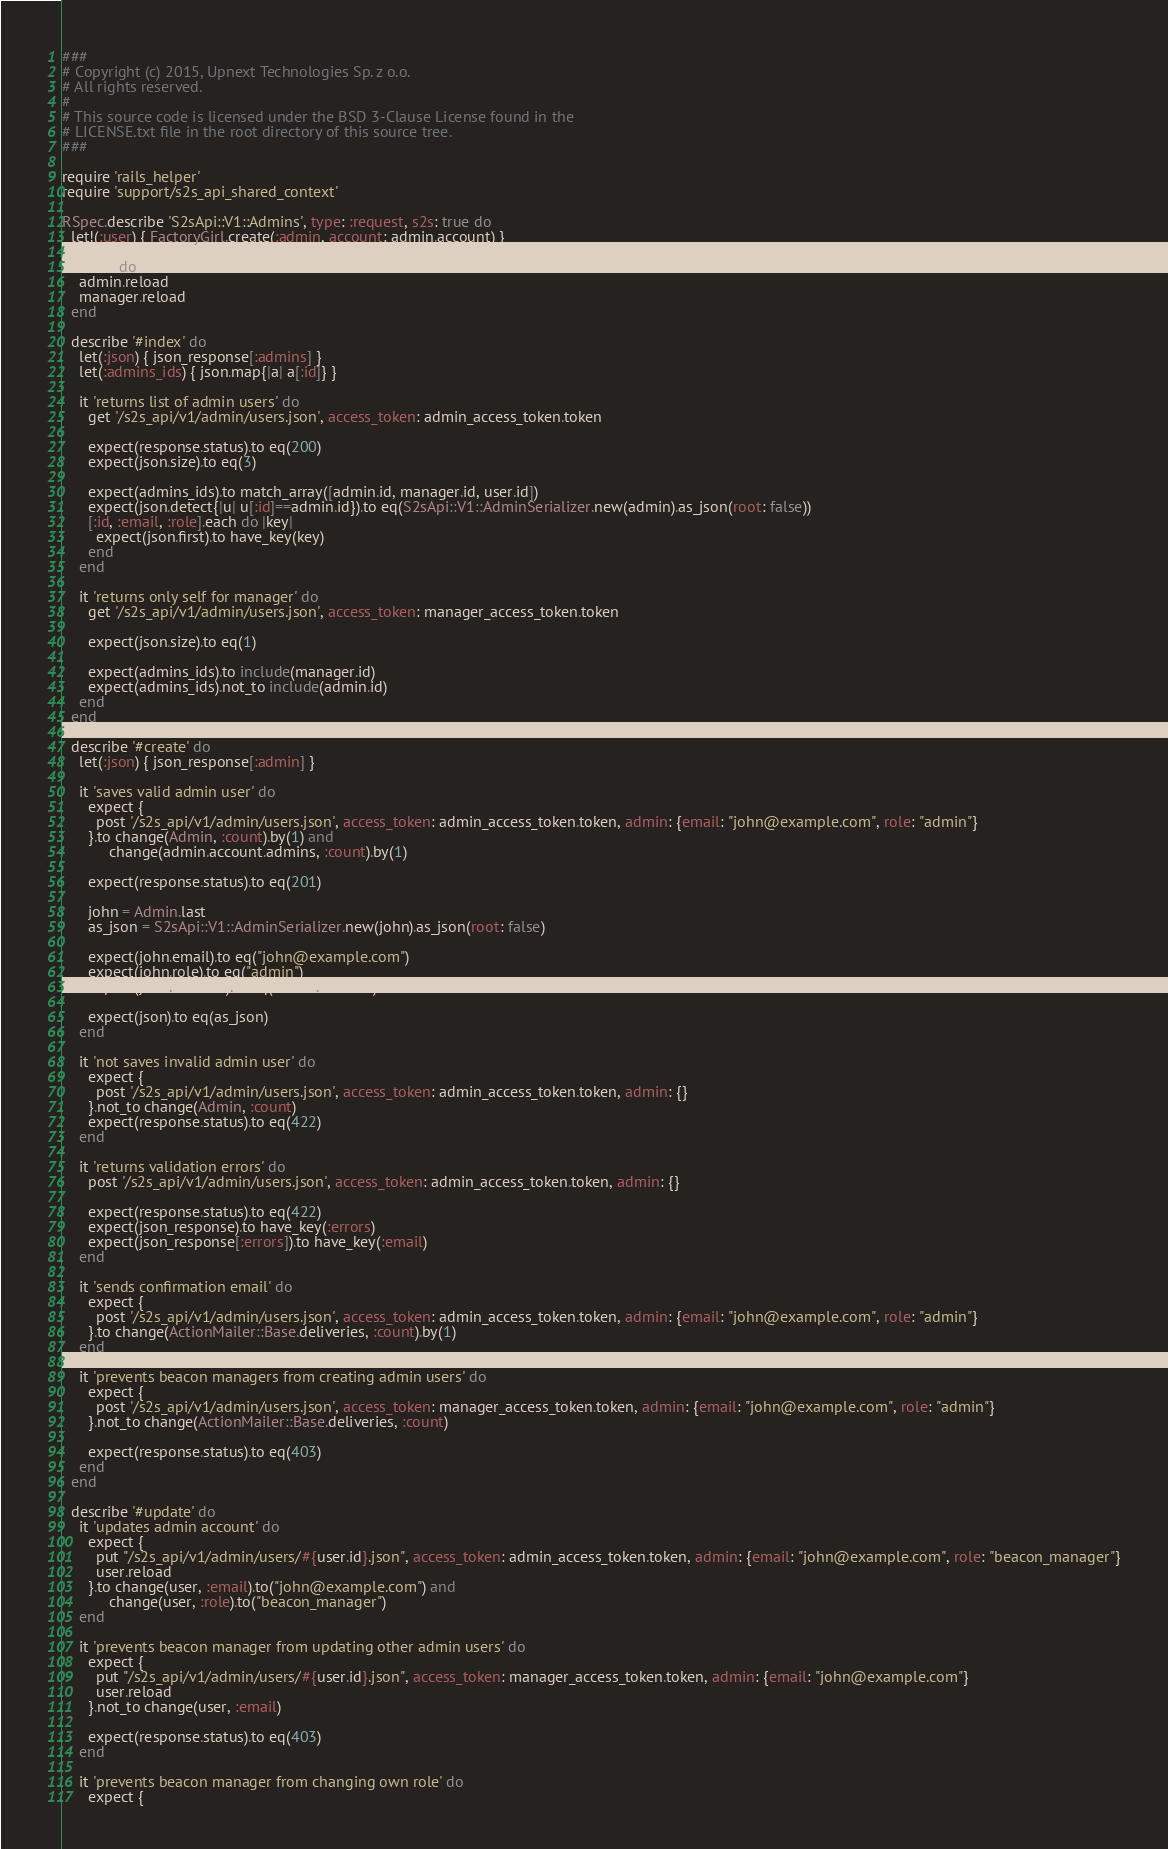Convert code to text. <code><loc_0><loc_0><loc_500><loc_500><_Ruby_>###
# Copyright (c) 2015, Upnext Technologies Sp. z o.o.
# All rights reserved.
#
# This source code is licensed under the BSD 3-Clause License found in the
# LICENSE.txt file in the root directory of this source tree. 
###

require 'rails_helper'
require 'support/s2s_api_shared_context'

RSpec.describe 'S2sApi::V1::Admins', type: :request, s2s: true do
  let!(:user) { FactoryGirl.create(:admin, account: admin.account) }

  before do
    admin.reload
    manager.reload
  end

  describe '#index' do
    let(:json) { json_response[:admins] }
    let(:admins_ids) { json.map{|a| a[:id]} }

    it 'returns list of admin users' do
      get '/s2s_api/v1/admin/users.json', access_token: admin_access_token.token

      expect(response.status).to eq(200)
      expect(json.size).to eq(3)

      expect(admins_ids).to match_array([admin.id, manager.id, user.id])
      expect(json.detect{|u| u[:id]==admin.id}).to eq(S2sApi::V1::AdminSerializer.new(admin).as_json(root: false))
      [:id, :email, :role].each do |key|
        expect(json.first).to have_key(key)
      end
    end

    it 'returns only self for manager' do
      get '/s2s_api/v1/admin/users.json', access_token: manager_access_token.token

      expect(json.size).to eq(1)

      expect(admins_ids).to include(manager.id)
      expect(admins_ids).not_to include(admin.id)
    end
  end

  describe '#create' do
    let(:json) { json_response[:admin] }

    it 'saves valid admin user' do
      expect {
        post '/s2s_api/v1/admin/users.json', access_token: admin_access_token.token, admin: {email: "john@example.com", role: "admin"}
      }.to change(Admin, :count).by(1) and
           change(admin.account.admins, :count).by(1)

      expect(response.status).to eq(201)

      john = Admin.last
      as_json = S2sApi::V1::AdminSerializer.new(john).as_json(root: false)

      expect(john.email).to eq("john@example.com")
      expect(john.role).to eq("admin")
      expect(john.account).to eq(admin.account)

      expect(json).to eq(as_json)
    end

    it 'not saves invalid admin user' do
      expect {
        post '/s2s_api/v1/admin/users.json', access_token: admin_access_token.token, admin: {}
      }.not_to change(Admin, :count)
      expect(response.status).to eq(422)
    end

    it 'returns validation errors' do
      post '/s2s_api/v1/admin/users.json', access_token: admin_access_token.token, admin: {}

      expect(response.status).to eq(422)
      expect(json_response).to have_key(:errors)
      expect(json_response[:errors]).to have_key(:email)
    end

    it 'sends confirmation email' do
      expect {
        post '/s2s_api/v1/admin/users.json', access_token: admin_access_token.token, admin: {email: "john@example.com", role: "admin"}
      }.to change(ActionMailer::Base.deliveries, :count).by(1)
    end

    it 'prevents beacon managers from creating admin users' do
      expect {
        post '/s2s_api/v1/admin/users.json', access_token: manager_access_token.token, admin: {email: "john@example.com", role: "admin"}
      }.not_to change(ActionMailer::Base.deliveries, :count)

      expect(response.status).to eq(403)
    end
  end

  describe '#update' do
    it 'updates admin account' do
      expect {
        put "/s2s_api/v1/admin/users/#{user.id}.json", access_token: admin_access_token.token, admin: {email: "john@example.com", role: "beacon_manager"}
        user.reload
      }.to change(user, :email).to("john@example.com") and
           change(user, :role).to("beacon_manager")
    end

    it 'prevents beacon manager from updating other admin users' do
      expect {
        put "/s2s_api/v1/admin/users/#{user.id}.json", access_token: manager_access_token.token, admin: {email: "john@example.com"}
        user.reload
      }.not_to change(user, :email)

      expect(response.status).to eq(403)
    end

    it 'prevents beacon manager from changing own role' do
      expect {</code> 